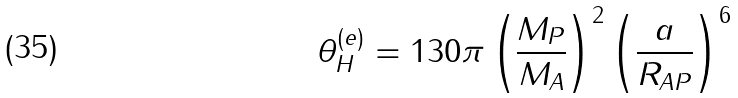<formula> <loc_0><loc_0><loc_500><loc_500>\theta _ { H } ^ { ( e ) } = 1 3 0 \pi \left ( \frac { M _ { P } } { M _ { A } } \right ) ^ { 2 } \left ( \frac { a } { R _ { A P } } \right ) ^ { 6 }</formula> 